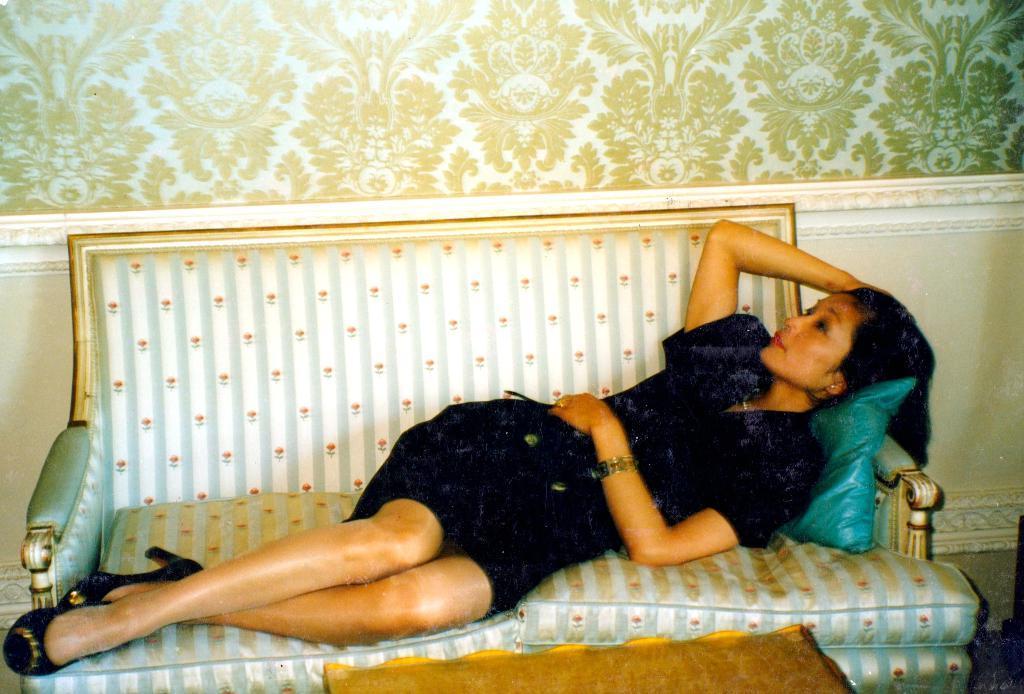Could you give a brief overview of what you see in this image? In this picture I can observe a woman laying on the sofa. She is wearing black color dress. In the background I can observe a wall. 